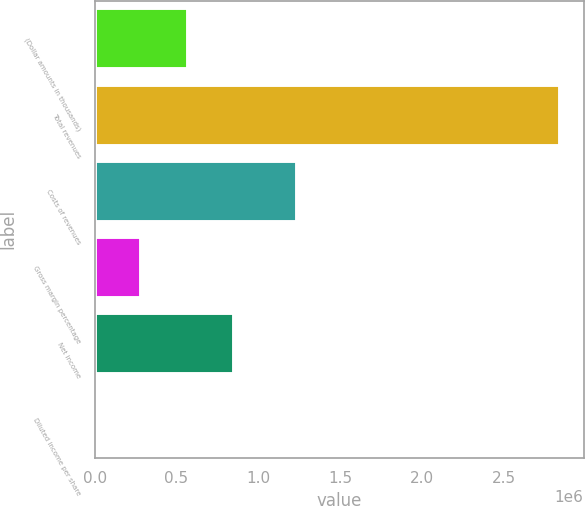Convert chart to OTSL. <chart><loc_0><loc_0><loc_500><loc_500><bar_chart><fcel>(Dollar amounts in thousands)<fcel>Total revenues<fcel>Costs of revenues<fcel>Gross margin percentage<fcel>Net income<fcel>Diluted income per share<nl><fcel>568559<fcel>2.84278e+06<fcel>1.23745e+06<fcel>284281<fcel>852837<fcel>3.21<nl></chart> 